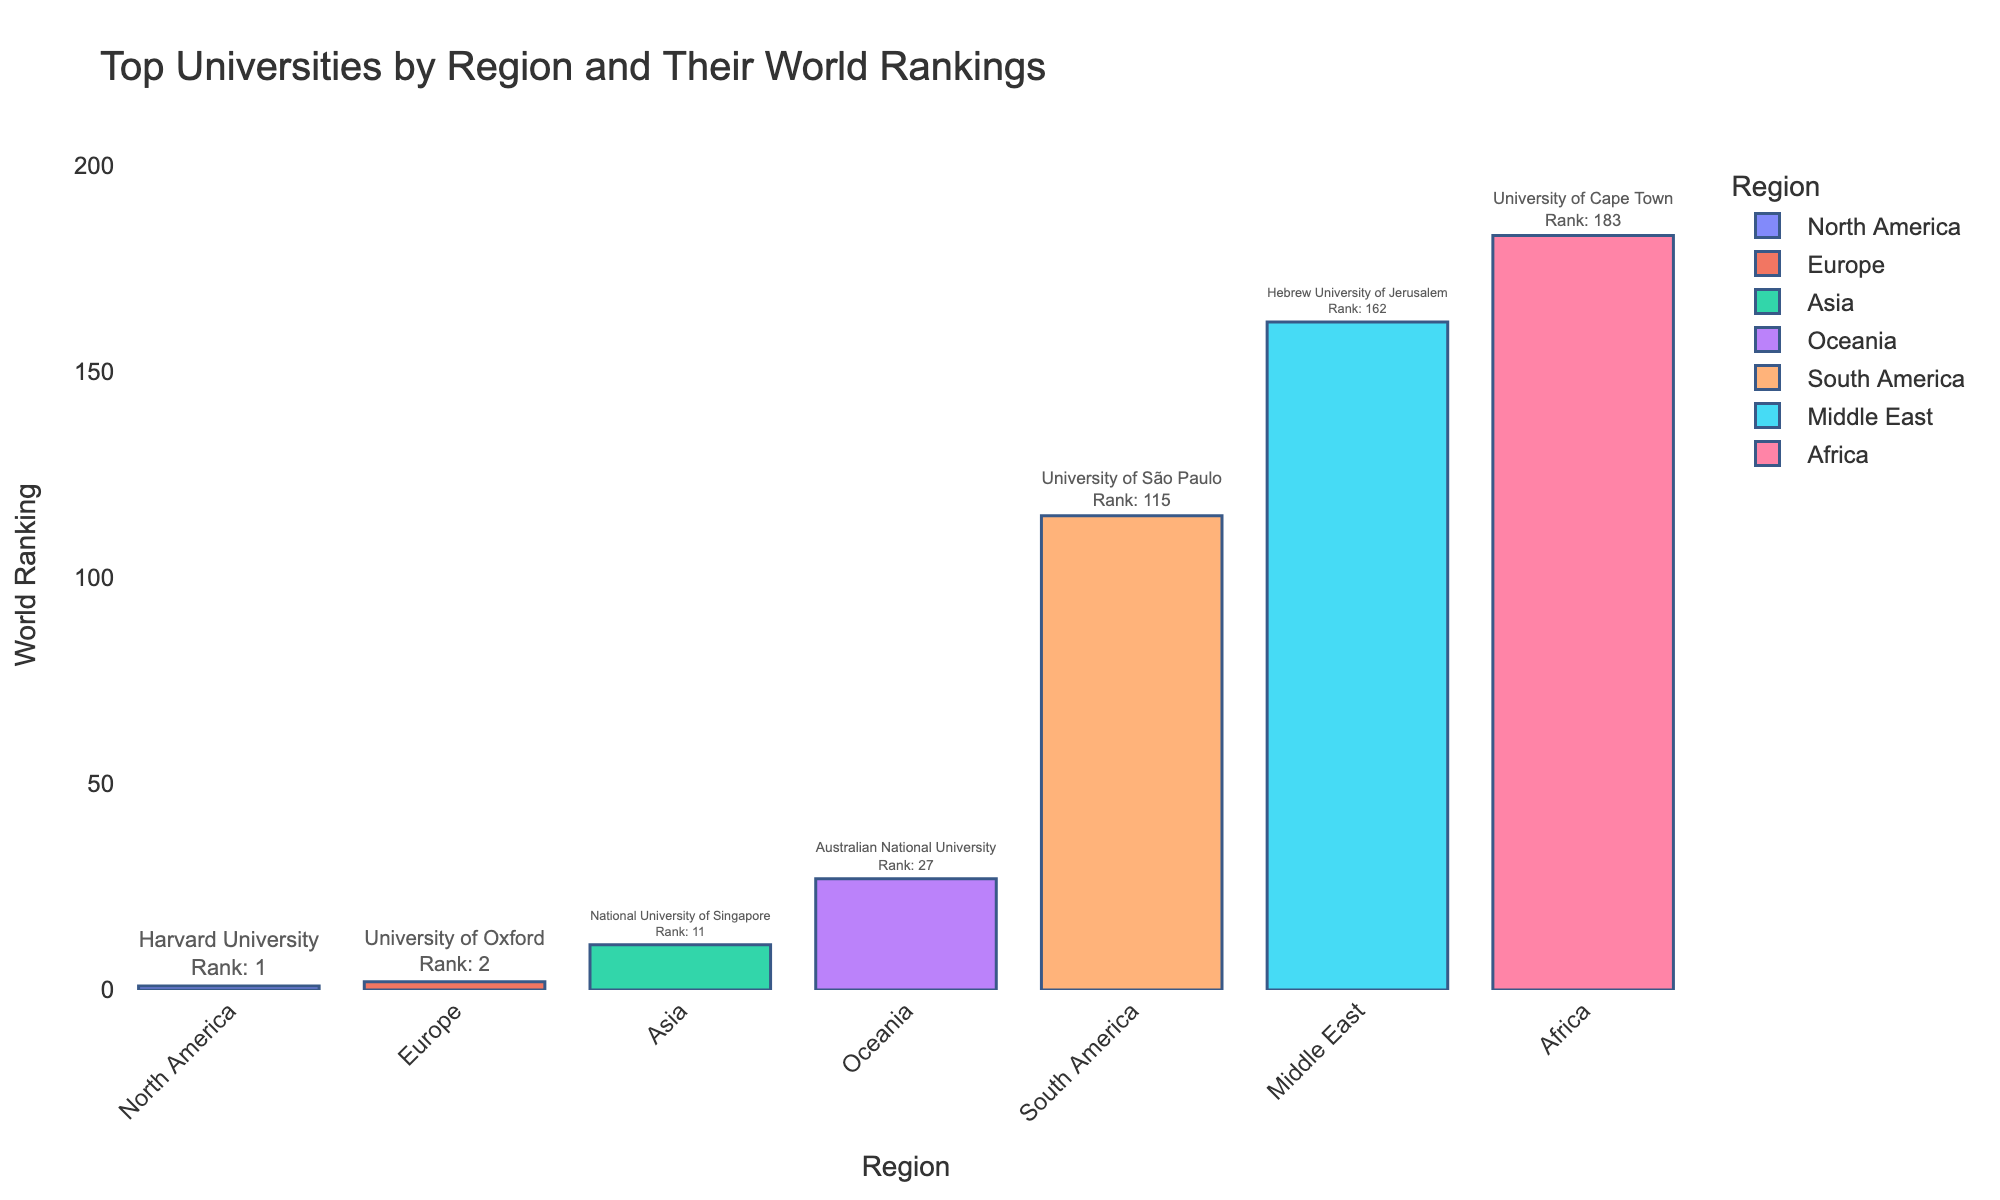What's the top-ranked university in North America? The figure shows a bar chart with regions on the x-axis and their top universities labeled. For North America, Harvard University is labeled as the top university.
Answer: Harvard University Which region has the highest-ranked university? By looking at the bar heights, North America has the highest-ranked university with Harvard University at rank 1.
Answer: North America Which university in Europe ranks 9th in the world? The bar labeled for Europe indicates ETH Zurich as being ranked 9th globally.
Answer: ETH Zurich What's the average world ranking of the top universities in the regions displayed? Sum the world rankings of all top universities: 1, 2, 16, 33, 115, 183, 190, 8, 9, 11, 27, 207, 254, 162. That equals 1218. There are 14 universities, so 1218 / 14 = 87.
Answer: 87 Which region's top university is ranked the lowest in the world? The figure shows that South America's Universidade Estadual de Campinas has the lowest rank at 207 in the world.
Answer: South America What's the range of world rankings for the top universities by region? The range is calculated by subtracting the smallest rank from the largest rank. The top university ranks range from 1 (Harvard University) to 254 (University of the Witwatersrand). So, 254 - 1 = 253.
Answer: 253 How many universities from the Middle East are shown, and what are their rankings? The figure shows two universities from the Middle East: King Abdulaziz University with a ranking of 190 and Hebrew University of Jerusalem with a ranking of 162.
Answer: 2, 190 and 162 Compare the world rankings of top universities in Oceania. Which one ranks higher? The figure shows University of Melbourne rank 33 and Australian National University rank 27. The Australian National University ranks higher.
Answer: Australian National University Which regions have a top university with a world ranking above 100? The regions with universities ranked above 100 are South America (115 and 207), Africa (183 and 254), and the Middle East (190 and 162).
Answer: South America, Africa, and the Middle East What is the world ranking difference between the top universities in North America and South America? The top university in North America (Harvard University) has a ranking of 1, and in South America (University of São Paulo) has a ranking of 115. The difference is 115 - 1 = 114.
Answer: 114 